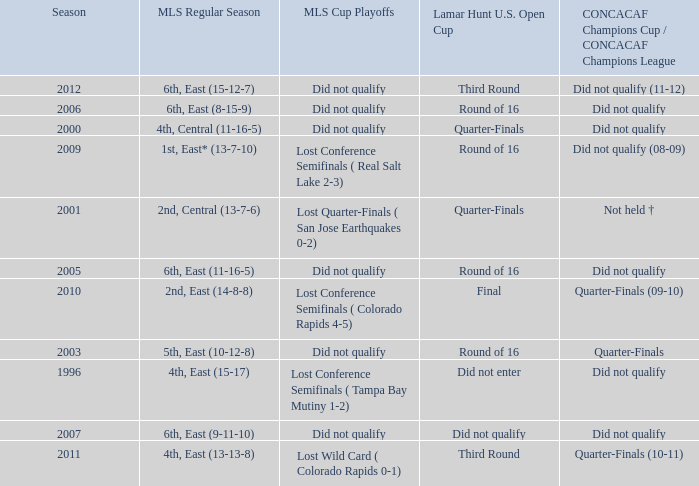What was the mls cup playoffs when the mls regular season was 4th, central (11-16-5)? Did not qualify. 